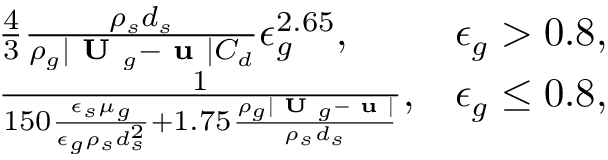Convert formula to latex. <formula><loc_0><loc_0><loc_500><loc_500>\begin{array} { r l r } & { \frac { 4 } { 3 } \frac { \rho _ { s } d _ { s } } { \rho _ { g } | U _ { g } - u | C _ { d } } \epsilon _ { g } ^ { 2 . 6 5 } , } & { \epsilon _ { g } > 0 . 8 , } \\ & { \frac { 1 } { 1 5 0 \frac { \epsilon _ { s } \mu _ { g } } { \epsilon _ { g } \rho _ { s } d _ { s } ^ { 2 } } + 1 . 7 5 \frac { \rho _ { g } | U _ { g } - u | } { \rho _ { s } d _ { s } } } , } & { \epsilon _ { g } \leq 0 . 8 , } \end{array}</formula> 